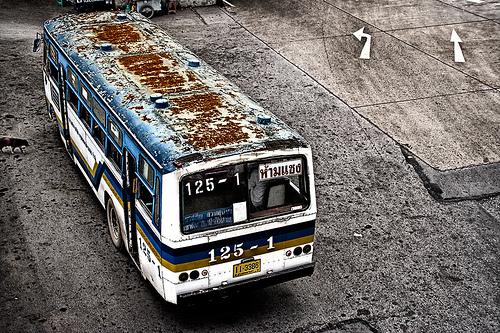Does the bus have rust?
Answer briefly. Yes. Are the white arrows painted on the pavement?
Keep it brief. Yes. What is the number of the bus?
Write a very short answer. 125-1. 